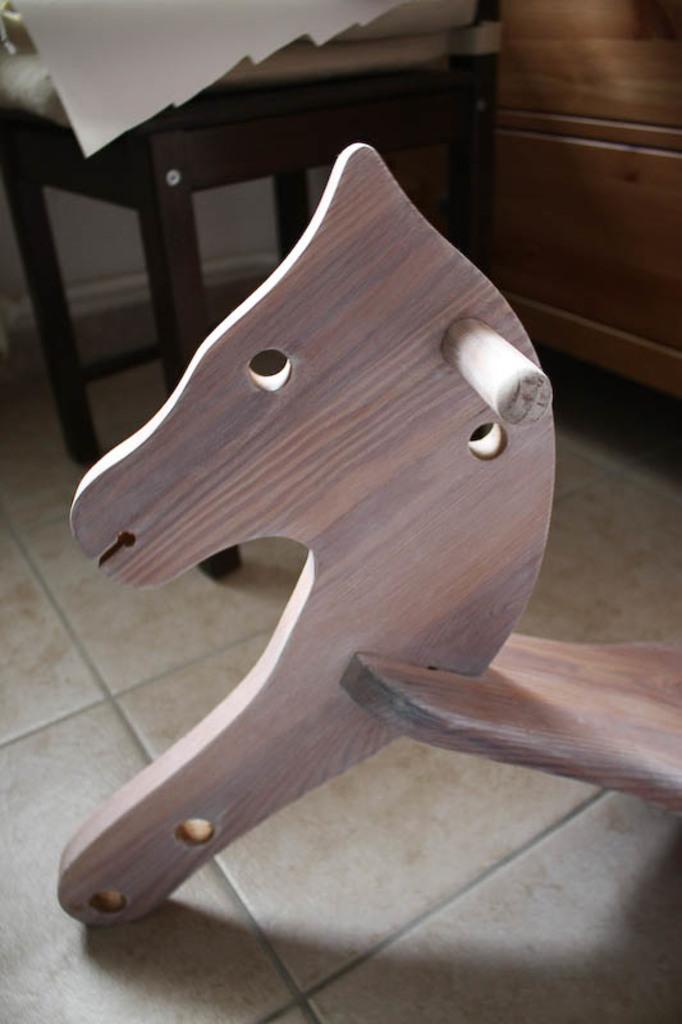How would you summarize this image in a sentence or two? In this image I can see a chair and some wooden objects on the floor. 